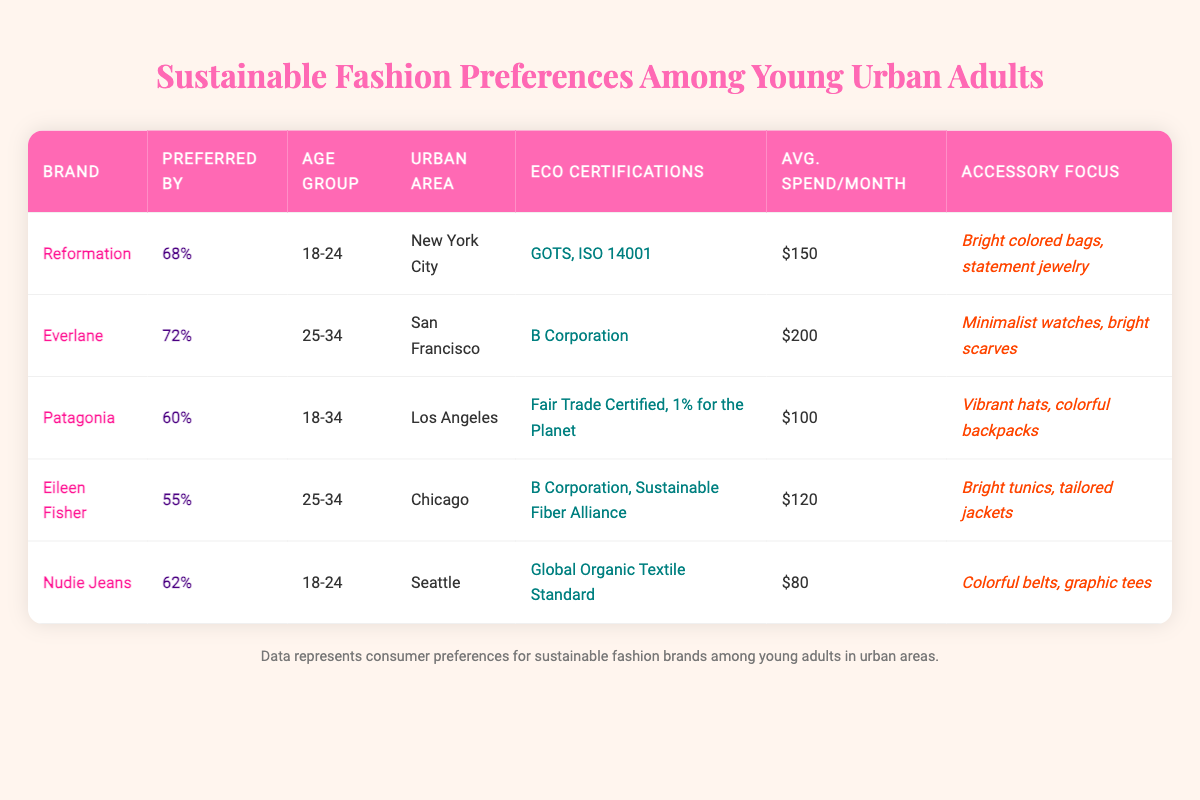What percentage of young adults in San Francisco prefer Everlane? The table shows that Everlane is preferred by 72% of young adults in San Francisco.
Answer: 72% Which brand has the highest average spend per month? By reviewing the average spend per month for each brand, Everlane at $200 holds the highest value when compared to others.
Answer: Everlane True or False: Patagonia has eco certifications that include GOTS. The table indicates that Patagonia’s eco certifications are Fair Trade Certified and 1% for the Planet, and it does not list GOTS as one of its certifications.
Answer: False What is the combined preferred percentage of Reformation and Nudie Jeans among young adults aged 18-24? From the table, Reformation is preferred by 68% and Nudie Jeans by 62%. Adding these two gives 68 + 62 = 130%.
Answer: 130% Which urban area has the lowest average spend per month among the brands listed? Analyzing the average spend, Nudie Jeans in Seattle has the lowest at $80 compared to others.
Answer: Seattle 